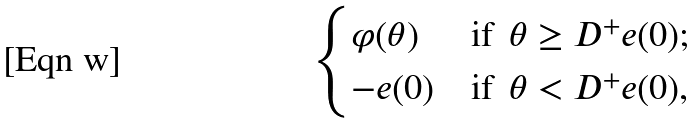<formula> <loc_0><loc_0><loc_500><loc_500>\begin{cases} \varphi ( \theta ) & \text {if } \, \theta \geq D ^ { + } e ( 0 ) ; \\ - e ( 0 ) & \text {if } \, \theta < D ^ { + } e ( 0 ) , \end{cases}</formula> 